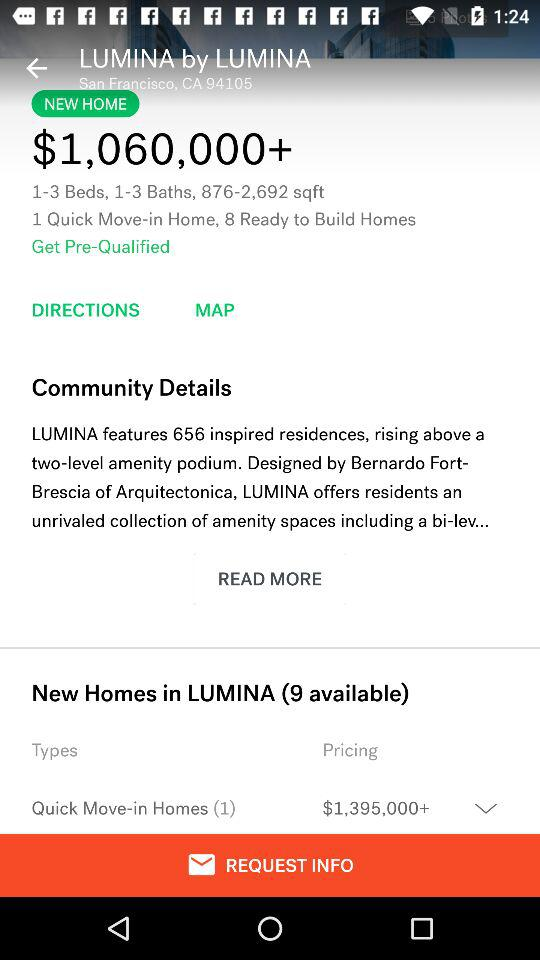How many more ready to build homes are there than quick move-in homes?
Answer the question using a single word or phrase. 7 